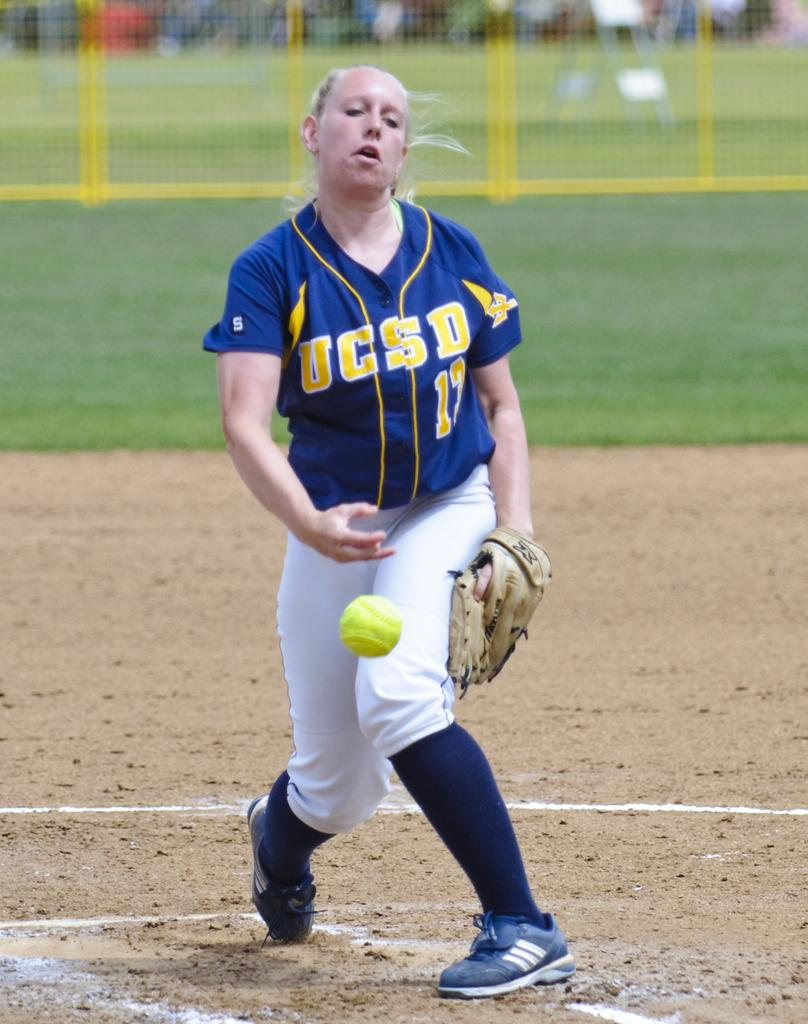<image>
Relay a brief, clear account of the picture shown. The female player trying to catch the ball wears a UCSD top. 